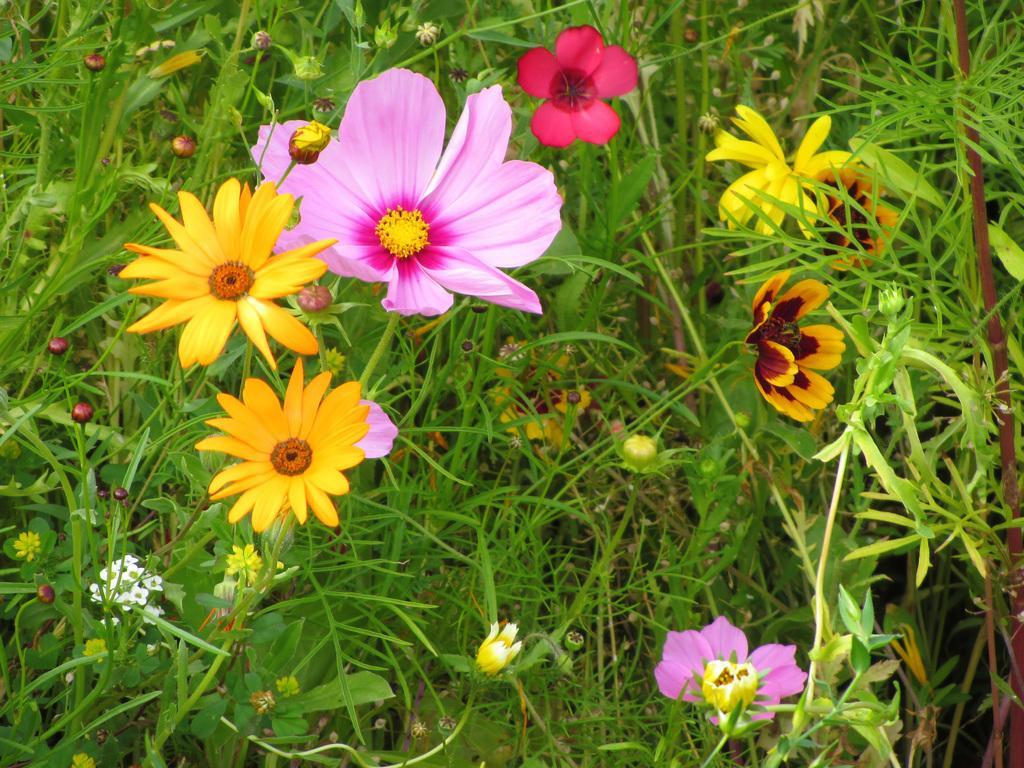How would you summarize this image in a sentence or two? In this picture we can see there are plants with leaves and different color flowers and buds. 